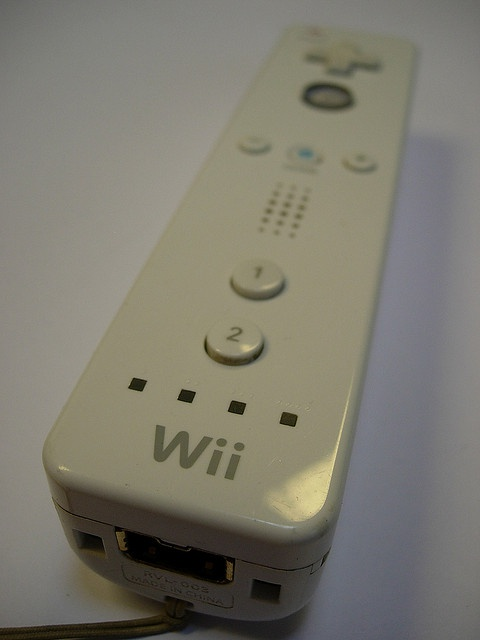Describe the objects in this image and their specific colors. I can see a remote in gray, black, and darkgreen tones in this image. 